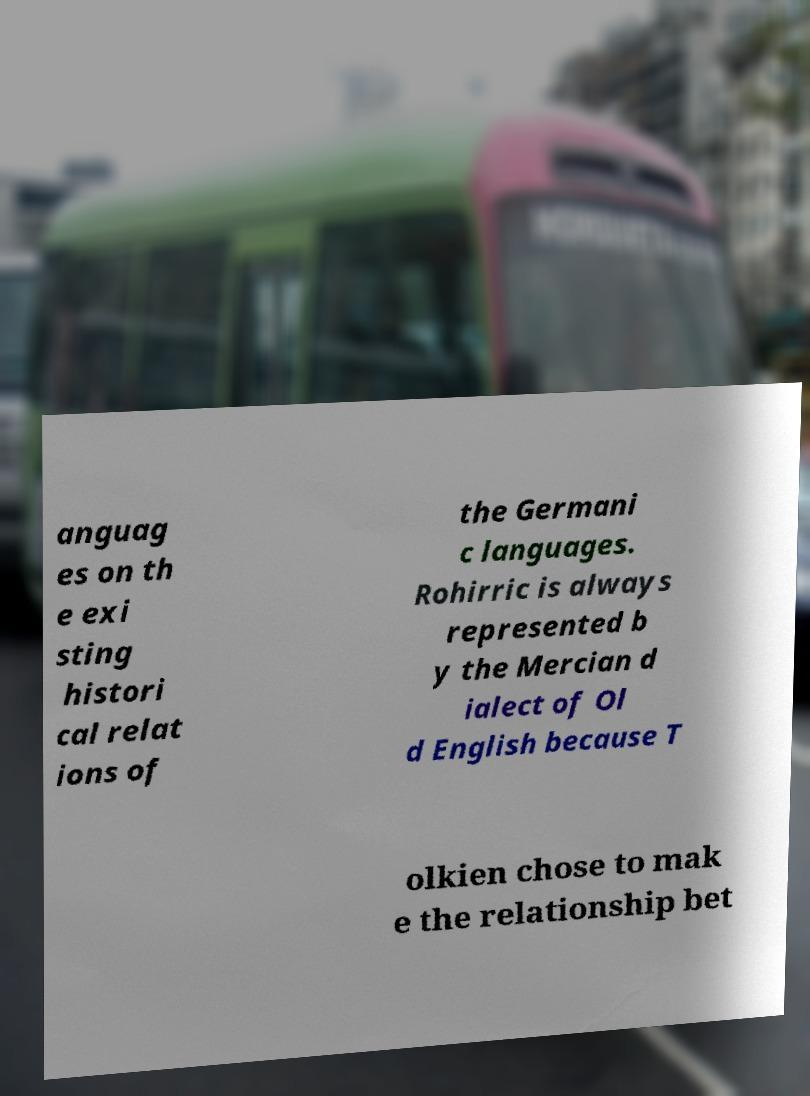Could you extract and type out the text from this image? anguag es on th e exi sting histori cal relat ions of the Germani c languages. Rohirric is always represented b y the Mercian d ialect of Ol d English because T olkien chose to mak e the relationship bet 